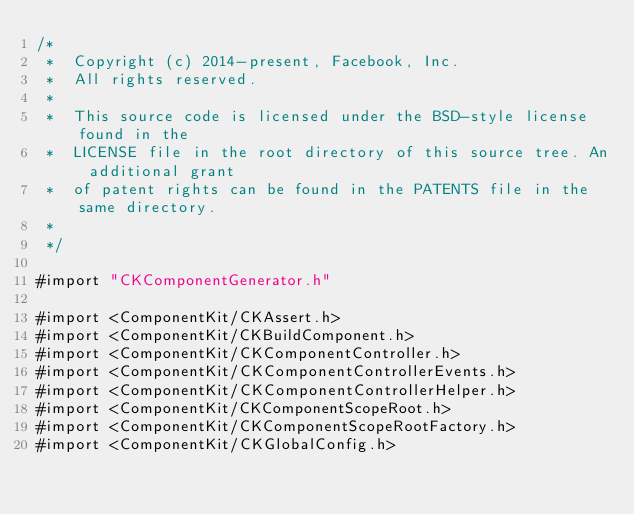Convert code to text. <code><loc_0><loc_0><loc_500><loc_500><_ObjectiveC_>/*
 *  Copyright (c) 2014-present, Facebook, Inc.
 *  All rights reserved.
 *
 *  This source code is licensed under the BSD-style license found in the
 *  LICENSE file in the root directory of this source tree. An additional grant
 *  of patent rights can be found in the PATENTS file in the same directory.
 *
 */

#import "CKComponentGenerator.h"

#import <ComponentKit/CKAssert.h>
#import <ComponentKit/CKBuildComponent.h>
#import <ComponentKit/CKComponentController.h>
#import <ComponentKit/CKComponentControllerEvents.h>
#import <ComponentKit/CKComponentControllerHelper.h>
#import <ComponentKit/CKComponentScopeRoot.h>
#import <ComponentKit/CKComponentScopeRootFactory.h>
#import <ComponentKit/CKGlobalConfig.h></code> 